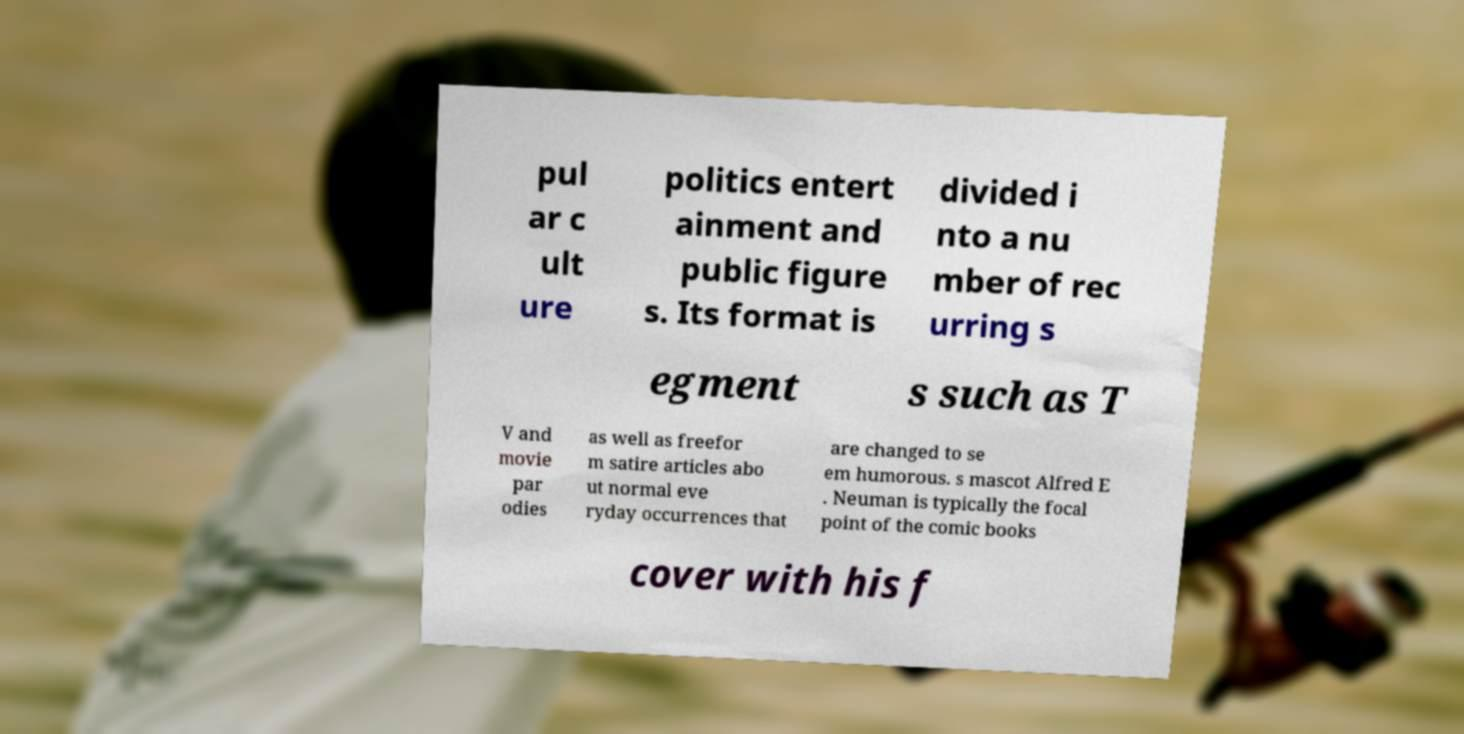What messages or text are displayed in this image? I need them in a readable, typed format. pul ar c ult ure politics entert ainment and public figure s. Its format is divided i nto a nu mber of rec urring s egment s such as T V and movie par odies as well as freefor m satire articles abo ut normal eve ryday occurrences that are changed to se em humorous. s mascot Alfred E . Neuman is typically the focal point of the comic books cover with his f 